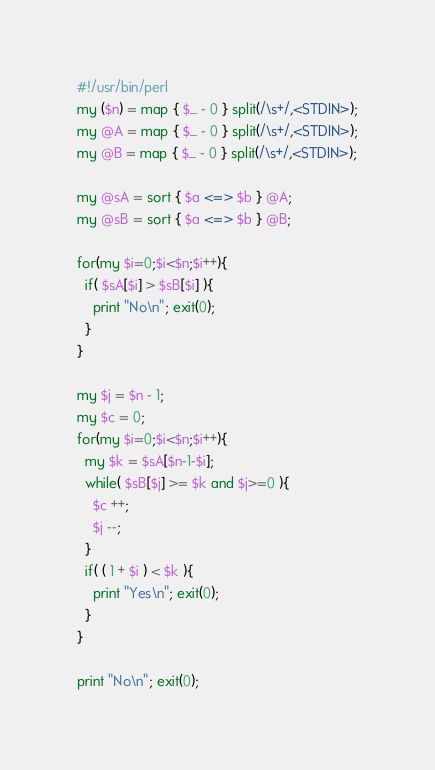<code> <loc_0><loc_0><loc_500><loc_500><_Perl_>#!/usr/bin/perl
my ($n) = map { $_ - 0 } split(/\s+/,<STDIN>);
my @A = map { $_ - 0 } split(/\s+/,<STDIN>);
my @B = map { $_ - 0 } split(/\s+/,<STDIN>);

my @sA = sort { $a <=> $b } @A;
my @sB = sort { $a <=> $b } @B;

for(my $i=0;$i<$n;$i++){
  if( $sA[$i] > $sB[$i] ){
    print "No\n"; exit(0);
  }
}

my $j = $n - 1;
my $c = 0;
for(my $i=0;$i<$n;$i++){
  my $k = $sA[$n-1-$i];
  while( $sB[$j] >= $k and $j>=0 ){
    $c ++;
    $j --;
  }
  if( ( 1 + $i ) < $k ){
    print "Yes\n"; exit(0);
  }
}

print "No\n"; exit(0);

</code> 